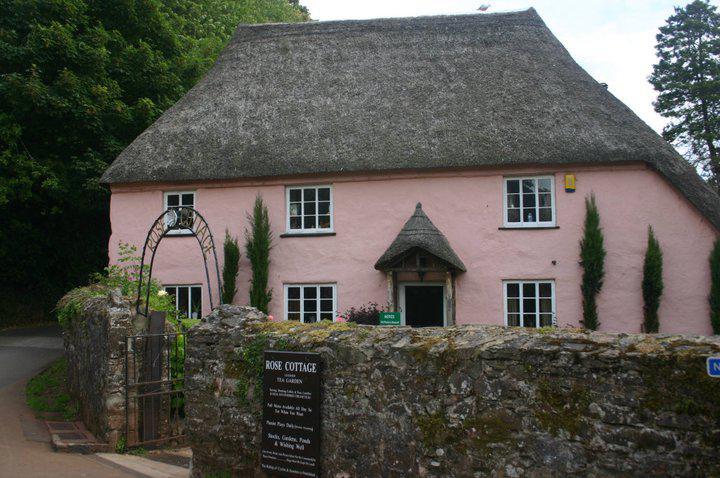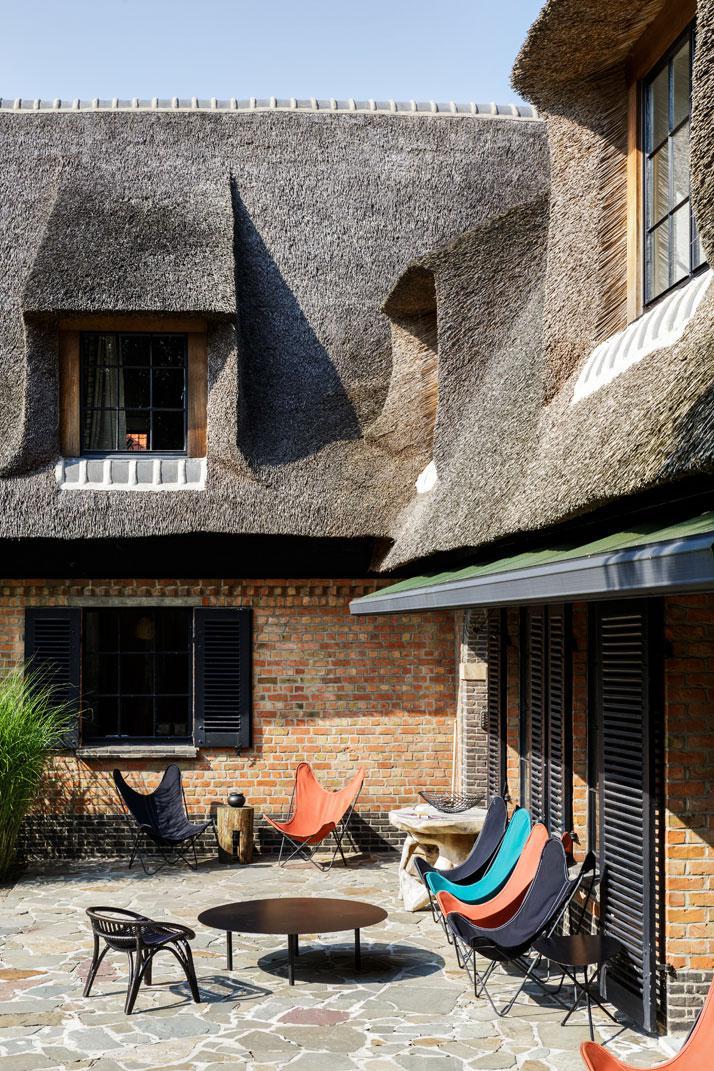The first image is the image on the left, the second image is the image on the right. Examine the images to the left and right. Is the description "One of the houses has posts at the edge of its roof." accurate? Answer yes or no. No. The first image is the image on the left, the second image is the image on the right. Considering the images on both sides, is "The structures on the left and right are simple boxy shapes with peaked thatch roofs featuring some kind of top border, but no curves or notches." valid? Answer yes or no. No. 